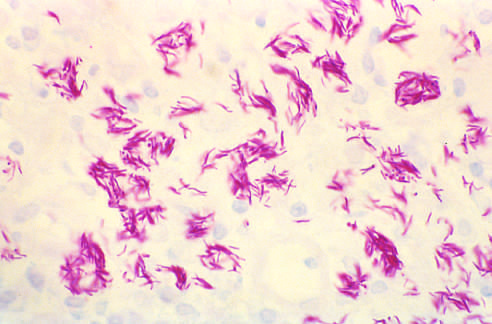does granulomatous host response not occur in the absence of appropriate t-cell-mediated immunity?
Answer the question using a single word or phrase. Yes 